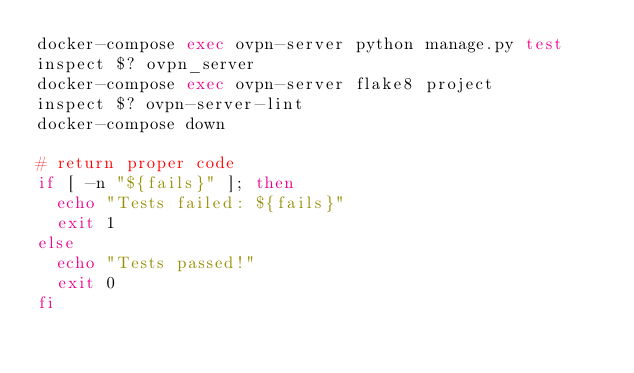<code> <loc_0><loc_0><loc_500><loc_500><_Bash_>docker-compose exec ovpn-server python manage.py test
inspect $? ovpn_server
docker-compose exec ovpn-server flake8 project
inspect $? ovpn-server-lint
docker-compose down

# return proper code
if [ -n "${fails}" ]; then
	echo "Tests failed: ${fails}"
	exit 1
else
	echo "Tests passed!"
	exit 0
fi
</code> 